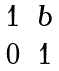Convert formula to latex. <formula><loc_0><loc_0><loc_500><loc_500>\begin{matrix} 1 & b \\ 0 & 1 \\ \end{matrix}</formula> 